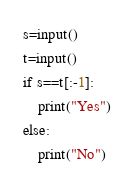<code> <loc_0><loc_0><loc_500><loc_500><_Python_>s=input()
t=input()
if s==t[:-1]:
    print("Yes")
else:
    print("No")</code> 